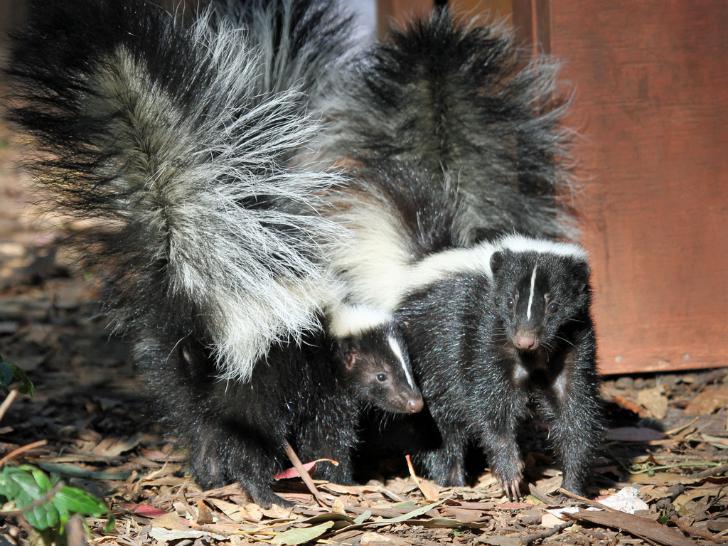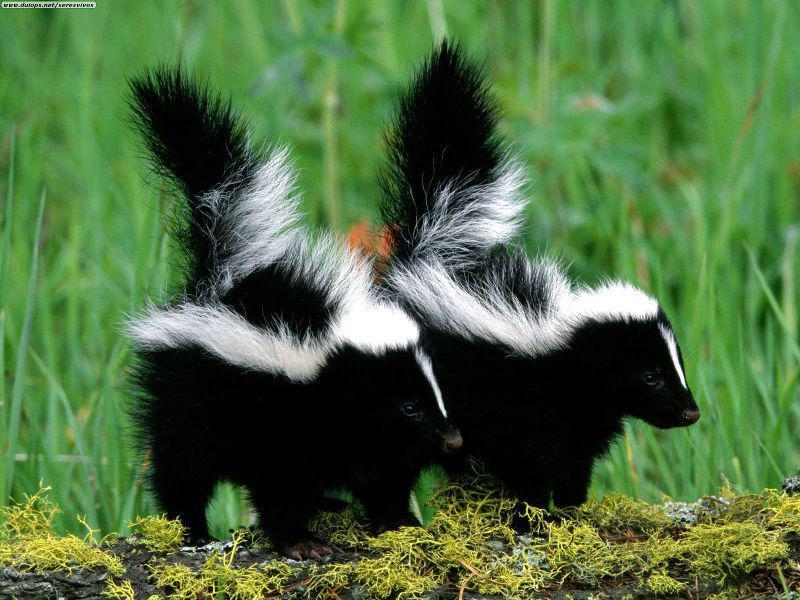The first image is the image on the left, the second image is the image on the right. For the images shown, is this caption "There are three skunks." true? Answer yes or no. No. The first image is the image on the left, the second image is the image on the right. Assess this claim about the two images: "One image contains a single skunk on all fours, and the other image features two side-by-side skunks with look-alike coloring and walking poses.". Correct or not? Answer yes or no. No. 